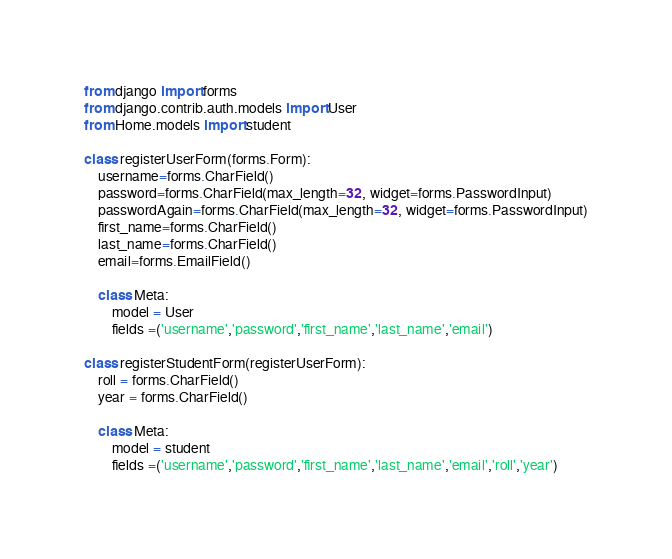Convert code to text. <code><loc_0><loc_0><loc_500><loc_500><_Python_>from django import forms
from django.contrib.auth.models import User
from Home.models import student

class registerUserForm(forms.Form):
    username=forms.CharField()
    password=forms.CharField(max_length=32, widget=forms.PasswordInput)
    passwordAgain=forms.CharField(max_length=32, widget=forms.PasswordInput)
    first_name=forms.CharField()
    last_name=forms.CharField()
    email=forms.EmailField()

    class Meta:
        model = User
        fields =('username','password','first_name','last_name','email')

class registerStudentForm(registerUserForm):
    roll = forms.CharField()
    year = forms.CharField()

    class Meta:
        model = student
        fields =('username','password','first_name','last_name','email','roll','year')
</code> 